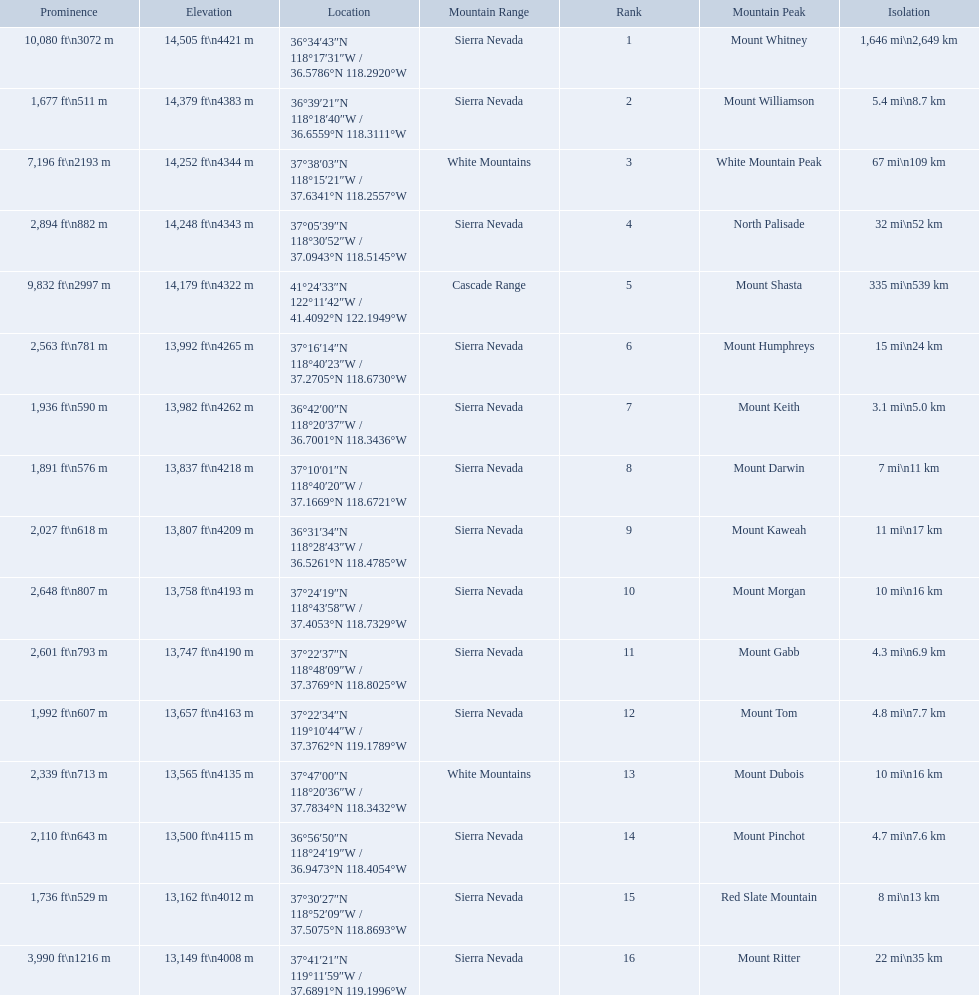What are the heights of the californian mountain peaks? 14,505 ft\n4421 m, 14,379 ft\n4383 m, 14,252 ft\n4344 m, 14,248 ft\n4343 m, 14,179 ft\n4322 m, 13,992 ft\n4265 m, 13,982 ft\n4262 m, 13,837 ft\n4218 m, 13,807 ft\n4209 m, 13,758 ft\n4193 m, 13,747 ft\n4190 m, 13,657 ft\n4163 m, 13,565 ft\n4135 m, 13,500 ft\n4115 m, 13,162 ft\n4012 m, 13,149 ft\n4008 m. What elevation is 13,149 ft or less? 13,149 ft\n4008 m. What mountain peak is at this elevation? Mount Ritter. What are the listed elevations? 14,505 ft\n4421 m, 14,379 ft\n4383 m, 14,252 ft\n4344 m, 14,248 ft\n4343 m, 14,179 ft\n4322 m, 13,992 ft\n4265 m, 13,982 ft\n4262 m, 13,837 ft\n4218 m, 13,807 ft\n4209 m, 13,758 ft\n4193 m, 13,747 ft\n4190 m, 13,657 ft\n4163 m, 13,565 ft\n4135 m, 13,500 ft\n4115 m, 13,162 ft\n4012 m, 13,149 ft\n4008 m. Which of those is 13,149 ft or below? 13,149 ft\n4008 m. To what mountain peak does that value correspond? Mount Ritter. 